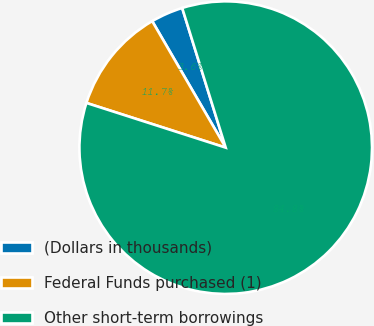Convert chart. <chart><loc_0><loc_0><loc_500><loc_500><pie_chart><fcel>(Dollars in thousands)<fcel>Federal Funds purchased (1)<fcel>Other short-term borrowings<nl><fcel>3.57%<fcel>11.68%<fcel>84.75%<nl></chart> 